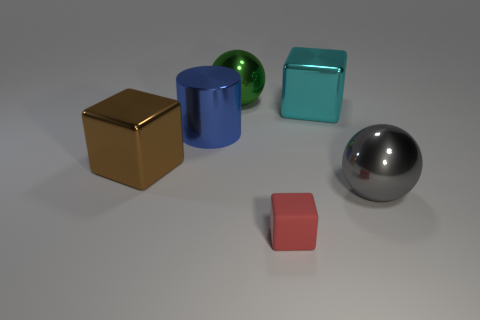Add 2 large yellow matte cylinders. How many objects exist? 8 Subtract all cylinders. How many objects are left? 5 Subtract 0 brown cylinders. How many objects are left? 6 Subtract all big gray rubber things. Subtract all brown shiny cubes. How many objects are left? 5 Add 6 large cubes. How many large cubes are left? 8 Add 2 metal cylinders. How many metal cylinders exist? 3 